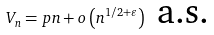Convert formula to latex. <formula><loc_0><loc_0><loc_500><loc_500>V _ { n } = p n + o \left ( n ^ { 1 / 2 + \varepsilon } \right ) \ \text {a.s.}</formula> 